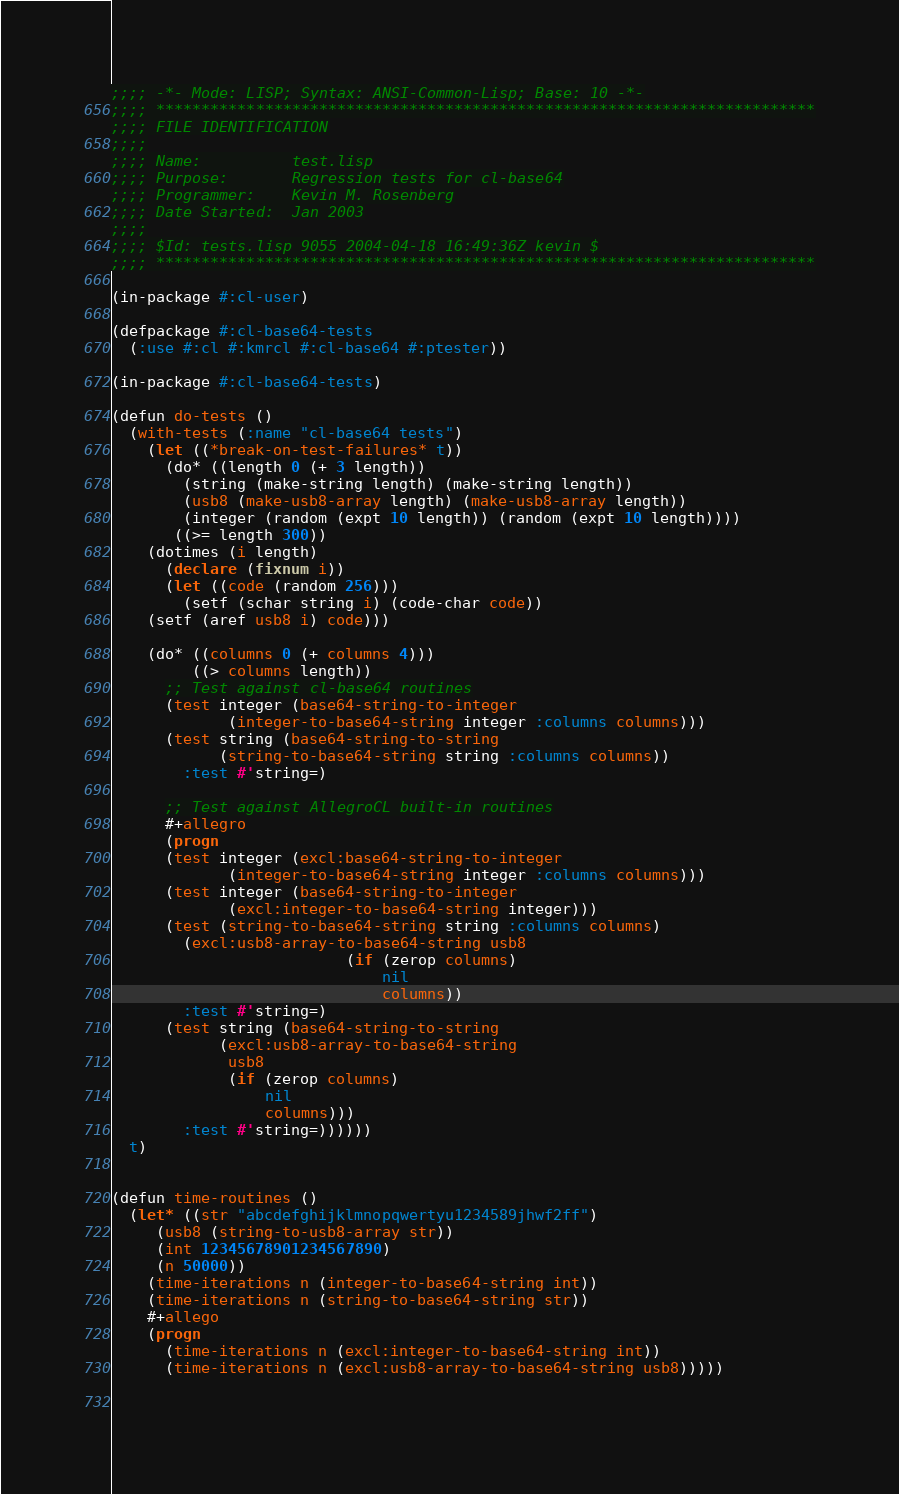<code> <loc_0><loc_0><loc_500><loc_500><_Lisp_>;;;; -*- Mode: LISP; Syntax: ANSI-Common-Lisp; Base: 10 -*-
;;;; *************************************************************************
;;;; FILE IDENTIFICATION
;;;;
;;;; Name:          test.lisp
;;;; Purpose:       Regression tests for cl-base64
;;;; Programmer:    Kevin M. Rosenberg
;;;; Date Started:  Jan 2003
;;;;
;;;; $Id: tests.lisp 9055 2004-04-18 16:49:36Z kevin $
;;;; *************************************************************************

(in-package #:cl-user)

(defpackage #:cl-base64-tests
  (:use #:cl #:kmrcl #:cl-base64 #:ptester))

(in-package #:cl-base64-tests)

(defun do-tests ()
  (with-tests (:name "cl-base64 tests")
    (let ((*break-on-test-failures* t))
      (do* ((length 0 (+ 3 length))
	    (string (make-string length) (make-string length))
	    (usb8 (make-usb8-array length) (make-usb8-array length))
	    (integer (random (expt 10 length)) (random (expt 10 length))))
	   ((>= length 300))
	(dotimes (i length)
	  (declare (fixnum i))
	  (let ((code (random 256)))
	    (setf (schar string i) (code-char code))
	(setf (aref usb8 i) code)))
	
	(do* ((columns 0 (+ columns 4)))
	     ((> columns length))
	  ;; Test against cl-base64 routines
	  (test integer (base64-string-to-integer
			 (integer-to-base64-string integer :columns columns)))
	  (test string (base64-string-to-string
			(string-to-base64-string string :columns columns))
		:test #'string=)
	  
	  ;; Test against AllegroCL built-in routines
	  #+allegro
	  (progn
	  (test integer (excl:base64-string-to-integer
			 (integer-to-base64-string integer :columns columns)))
	  (test integer (base64-string-to-integer
			 (excl:integer-to-base64-string integer)))
	  (test (string-to-base64-string string :columns columns)
		(excl:usb8-array-to-base64-string usb8
						  (if (zerop columns)
						      nil
						      columns))
		:test #'string=)
	  (test string (base64-string-to-string
			(excl:usb8-array-to-base64-string
			 usb8
			 (if (zerop columns)
			     nil
			     columns)))
		:test #'string=))))))
  t)


(defun time-routines ()
  (let* ((str "abcdefghijklmnopqwertyu1234589jhwf2ff")
	 (usb8 (string-to-usb8-array str))
	 (int 12345678901234567890)
	 (n 50000))
    (time-iterations n (integer-to-base64-string int))
    (time-iterations n (string-to-base64-string str))
    #+allego
    (progn
      (time-iterations n (excl:integer-to-base64-string int))
      (time-iterations n (excl:usb8-array-to-base64-string usb8)))))

      </code> 